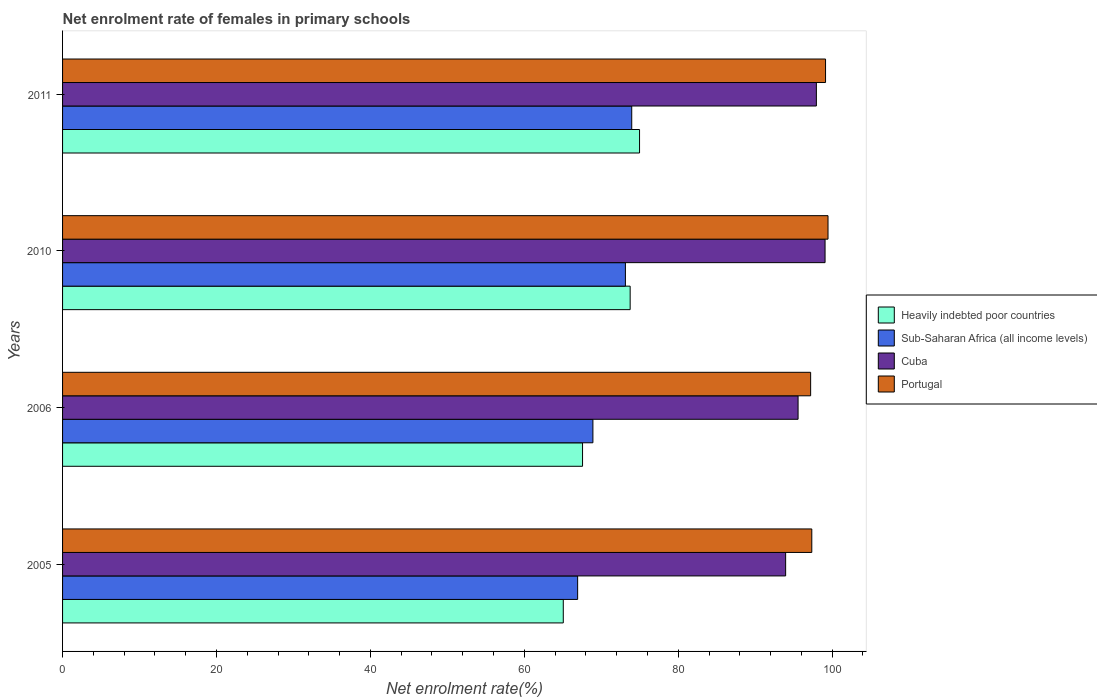Are the number of bars per tick equal to the number of legend labels?
Provide a succinct answer. Yes. How many bars are there on the 4th tick from the top?
Ensure brevity in your answer.  4. What is the net enrolment rate of females in primary schools in Portugal in 2010?
Keep it short and to the point. 99.46. Across all years, what is the maximum net enrolment rate of females in primary schools in Portugal?
Offer a very short reply. 99.46. Across all years, what is the minimum net enrolment rate of females in primary schools in Cuba?
Keep it short and to the point. 93.95. In which year was the net enrolment rate of females in primary schools in Heavily indebted poor countries maximum?
Ensure brevity in your answer.  2011. In which year was the net enrolment rate of females in primary schools in Portugal minimum?
Your answer should be very brief. 2006. What is the total net enrolment rate of females in primary schools in Sub-Saharan Africa (all income levels) in the graph?
Keep it short and to the point. 282.92. What is the difference between the net enrolment rate of females in primary schools in Heavily indebted poor countries in 2005 and that in 2011?
Provide a succinct answer. -9.91. What is the difference between the net enrolment rate of females in primary schools in Portugal in 2006 and the net enrolment rate of females in primary schools in Cuba in 2011?
Your answer should be very brief. -0.75. What is the average net enrolment rate of females in primary schools in Sub-Saharan Africa (all income levels) per year?
Make the answer very short. 70.73. In the year 2010, what is the difference between the net enrolment rate of females in primary schools in Portugal and net enrolment rate of females in primary schools in Sub-Saharan Africa (all income levels)?
Make the answer very short. 26.33. What is the ratio of the net enrolment rate of females in primary schools in Sub-Saharan Africa (all income levels) in 2005 to that in 2010?
Your answer should be very brief. 0.92. Is the net enrolment rate of females in primary schools in Cuba in 2006 less than that in 2010?
Ensure brevity in your answer.  Yes. What is the difference between the highest and the second highest net enrolment rate of females in primary schools in Heavily indebted poor countries?
Make the answer very short. 1.22. What is the difference between the highest and the lowest net enrolment rate of females in primary schools in Heavily indebted poor countries?
Ensure brevity in your answer.  9.91. What does the 2nd bar from the top in 2006 represents?
Your answer should be very brief. Cuba. What does the 1st bar from the bottom in 2005 represents?
Your answer should be compact. Heavily indebted poor countries. Is it the case that in every year, the sum of the net enrolment rate of females in primary schools in Heavily indebted poor countries and net enrolment rate of females in primary schools in Cuba is greater than the net enrolment rate of females in primary schools in Sub-Saharan Africa (all income levels)?
Make the answer very short. Yes. How many bars are there?
Provide a short and direct response. 16. Are all the bars in the graph horizontal?
Your answer should be very brief. Yes. What is the difference between two consecutive major ticks on the X-axis?
Your answer should be compact. 20. Does the graph contain grids?
Your response must be concise. No. Where does the legend appear in the graph?
Give a very brief answer. Center right. How are the legend labels stacked?
Keep it short and to the point. Vertical. What is the title of the graph?
Keep it short and to the point. Net enrolment rate of females in primary schools. Does "United Kingdom" appear as one of the legend labels in the graph?
Ensure brevity in your answer.  No. What is the label or title of the X-axis?
Keep it short and to the point. Net enrolment rate(%). What is the label or title of the Y-axis?
Give a very brief answer. Years. What is the Net enrolment rate(%) in Heavily indebted poor countries in 2005?
Ensure brevity in your answer.  65.06. What is the Net enrolment rate(%) in Sub-Saharan Africa (all income levels) in 2005?
Offer a very short reply. 66.92. What is the Net enrolment rate(%) in Cuba in 2005?
Keep it short and to the point. 93.95. What is the Net enrolment rate(%) in Portugal in 2005?
Your response must be concise. 97.35. What is the Net enrolment rate(%) in Heavily indebted poor countries in 2006?
Provide a succinct answer. 67.56. What is the Net enrolment rate(%) in Sub-Saharan Africa (all income levels) in 2006?
Offer a very short reply. 68.91. What is the Net enrolment rate(%) in Cuba in 2006?
Give a very brief answer. 95.57. What is the Net enrolment rate(%) of Portugal in 2006?
Offer a terse response. 97.2. What is the Net enrolment rate(%) in Heavily indebted poor countries in 2010?
Keep it short and to the point. 73.75. What is the Net enrolment rate(%) in Sub-Saharan Africa (all income levels) in 2010?
Provide a short and direct response. 73.13. What is the Net enrolment rate(%) in Cuba in 2010?
Give a very brief answer. 99.07. What is the Net enrolment rate(%) of Portugal in 2010?
Provide a short and direct response. 99.46. What is the Net enrolment rate(%) in Heavily indebted poor countries in 2011?
Make the answer very short. 74.97. What is the Net enrolment rate(%) in Sub-Saharan Africa (all income levels) in 2011?
Offer a terse response. 73.95. What is the Net enrolment rate(%) in Cuba in 2011?
Your answer should be compact. 97.94. What is the Net enrolment rate(%) of Portugal in 2011?
Provide a short and direct response. 99.14. Across all years, what is the maximum Net enrolment rate(%) in Heavily indebted poor countries?
Give a very brief answer. 74.97. Across all years, what is the maximum Net enrolment rate(%) of Sub-Saharan Africa (all income levels)?
Ensure brevity in your answer.  73.95. Across all years, what is the maximum Net enrolment rate(%) in Cuba?
Make the answer very short. 99.07. Across all years, what is the maximum Net enrolment rate(%) of Portugal?
Offer a terse response. 99.46. Across all years, what is the minimum Net enrolment rate(%) in Heavily indebted poor countries?
Make the answer very short. 65.06. Across all years, what is the minimum Net enrolment rate(%) of Sub-Saharan Africa (all income levels)?
Your answer should be compact. 66.92. Across all years, what is the minimum Net enrolment rate(%) of Cuba?
Provide a short and direct response. 93.95. Across all years, what is the minimum Net enrolment rate(%) in Portugal?
Make the answer very short. 97.2. What is the total Net enrolment rate(%) of Heavily indebted poor countries in the graph?
Give a very brief answer. 281.34. What is the total Net enrolment rate(%) of Sub-Saharan Africa (all income levels) in the graph?
Offer a very short reply. 282.92. What is the total Net enrolment rate(%) in Cuba in the graph?
Your answer should be compact. 386.54. What is the total Net enrolment rate(%) in Portugal in the graph?
Make the answer very short. 393.14. What is the difference between the Net enrolment rate(%) in Heavily indebted poor countries in 2005 and that in 2006?
Offer a terse response. -2.5. What is the difference between the Net enrolment rate(%) in Sub-Saharan Africa (all income levels) in 2005 and that in 2006?
Your response must be concise. -1.98. What is the difference between the Net enrolment rate(%) of Cuba in 2005 and that in 2006?
Keep it short and to the point. -1.62. What is the difference between the Net enrolment rate(%) of Portugal in 2005 and that in 2006?
Your answer should be very brief. 0.15. What is the difference between the Net enrolment rate(%) in Heavily indebted poor countries in 2005 and that in 2010?
Your answer should be very brief. -8.69. What is the difference between the Net enrolment rate(%) of Sub-Saharan Africa (all income levels) in 2005 and that in 2010?
Offer a terse response. -6.21. What is the difference between the Net enrolment rate(%) of Cuba in 2005 and that in 2010?
Ensure brevity in your answer.  -5.12. What is the difference between the Net enrolment rate(%) in Portugal in 2005 and that in 2010?
Your response must be concise. -2.11. What is the difference between the Net enrolment rate(%) in Heavily indebted poor countries in 2005 and that in 2011?
Your response must be concise. -9.91. What is the difference between the Net enrolment rate(%) of Sub-Saharan Africa (all income levels) in 2005 and that in 2011?
Make the answer very short. -7.03. What is the difference between the Net enrolment rate(%) of Cuba in 2005 and that in 2011?
Provide a succinct answer. -3.99. What is the difference between the Net enrolment rate(%) of Portugal in 2005 and that in 2011?
Provide a succinct answer. -1.79. What is the difference between the Net enrolment rate(%) of Heavily indebted poor countries in 2006 and that in 2010?
Make the answer very short. -6.19. What is the difference between the Net enrolment rate(%) in Sub-Saharan Africa (all income levels) in 2006 and that in 2010?
Ensure brevity in your answer.  -4.22. What is the difference between the Net enrolment rate(%) of Cuba in 2006 and that in 2010?
Make the answer very short. -3.51. What is the difference between the Net enrolment rate(%) in Portugal in 2006 and that in 2010?
Ensure brevity in your answer.  -2.26. What is the difference between the Net enrolment rate(%) of Heavily indebted poor countries in 2006 and that in 2011?
Offer a very short reply. -7.41. What is the difference between the Net enrolment rate(%) in Sub-Saharan Africa (all income levels) in 2006 and that in 2011?
Make the answer very short. -5.05. What is the difference between the Net enrolment rate(%) in Cuba in 2006 and that in 2011?
Your response must be concise. -2.38. What is the difference between the Net enrolment rate(%) of Portugal in 2006 and that in 2011?
Make the answer very short. -1.94. What is the difference between the Net enrolment rate(%) of Heavily indebted poor countries in 2010 and that in 2011?
Provide a short and direct response. -1.22. What is the difference between the Net enrolment rate(%) of Sub-Saharan Africa (all income levels) in 2010 and that in 2011?
Provide a short and direct response. -0.82. What is the difference between the Net enrolment rate(%) of Cuba in 2010 and that in 2011?
Your response must be concise. 1.13. What is the difference between the Net enrolment rate(%) of Portugal in 2010 and that in 2011?
Your response must be concise. 0.32. What is the difference between the Net enrolment rate(%) of Heavily indebted poor countries in 2005 and the Net enrolment rate(%) of Sub-Saharan Africa (all income levels) in 2006?
Your answer should be compact. -3.85. What is the difference between the Net enrolment rate(%) of Heavily indebted poor countries in 2005 and the Net enrolment rate(%) of Cuba in 2006?
Ensure brevity in your answer.  -30.51. What is the difference between the Net enrolment rate(%) in Heavily indebted poor countries in 2005 and the Net enrolment rate(%) in Portugal in 2006?
Your answer should be compact. -32.14. What is the difference between the Net enrolment rate(%) of Sub-Saharan Africa (all income levels) in 2005 and the Net enrolment rate(%) of Cuba in 2006?
Provide a succinct answer. -28.64. What is the difference between the Net enrolment rate(%) of Sub-Saharan Africa (all income levels) in 2005 and the Net enrolment rate(%) of Portugal in 2006?
Offer a very short reply. -30.27. What is the difference between the Net enrolment rate(%) of Cuba in 2005 and the Net enrolment rate(%) of Portugal in 2006?
Provide a succinct answer. -3.25. What is the difference between the Net enrolment rate(%) of Heavily indebted poor countries in 2005 and the Net enrolment rate(%) of Sub-Saharan Africa (all income levels) in 2010?
Make the answer very short. -8.07. What is the difference between the Net enrolment rate(%) in Heavily indebted poor countries in 2005 and the Net enrolment rate(%) in Cuba in 2010?
Keep it short and to the point. -34.01. What is the difference between the Net enrolment rate(%) of Heavily indebted poor countries in 2005 and the Net enrolment rate(%) of Portugal in 2010?
Keep it short and to the point. -34.4. What is the difference between the Net enrolment rate(%) of Sub-Saharan Africa (all income levels) in 2005 and the Net enrolment rate(%) of Cuba in 2010?
Offer a very short reply. -32.15. What is the difference between the Net enrolment rate(%) of Sub-Saharan Africa (all income levels) in 2005 and the Net enrolment rate(%) of Portugal in 2010?
Your answer should be very brief. -32.53. What is the difference between the Net enrolment rate(%) of Cuba in 2005 and the Net enrolment rate(%) of Portugal in 2010?
Keep it short and to the point. -5.51. What is the difference between the Net enrolment rate(%) in Heavily indebted poor countries in 2005 and the Net enrolment rate(%) in Sub-Saharan Africa (all income levels) in 2011?
Give a very brief answer. -8.89. What is the difference between the Net enrolment rate(%) of Heavily indebted poor countries in 2005 and the Net enrolment rate(%) of Cuba in 2011?
Your answer should be compact. -32.88. What is the difference between the Net enrolment rate(%) in Heavily indebted poor countries in 2005 and the Net enrolment rate(%) in Portugal in 2011?
Offer a terse response. -34.08. What is the difference between the Net enrolment rate(%) of Sub-Saharan Africa (all income levels) in 2005 and the Net enrolment rate(%) of Cuba in 2011?
Make the answer very short. -31.02. What is the difference between the Net enrolment rate(%) of Sub-Saharan Africa (all income levels) in 2005 and the Net enrolment rate(%) of Portugal in 2011?
Ensure brevity in your answer.  -32.21. What is the difference between the Net enrolment rate(%) of Cuba in 2005 and the Net enrolment rate(%) of Portugal in 2011?
Provide a succinct answer. -5.18. What is the difference between the Net enrolment rate(%) in Heavily indebted poor countries in 2006 and the Net enrolment rate(%) in Sub-Saharan Africa (all income levels) in 2010?
Keep it short and to the point. -5.57. What is the difference between the Net enrolment rate(%) in Heavily indebted poor countries in 2006 and the Net enrolment rate(%) in Cuba in 2010?
Your response must be concise. -31.51. What is the difference between the Net enrolment rate(%) of Heavily indebted poor countries in 2006 and the Net enrolment rate(%) of Portugal in 2010?
Keep it short and to the point. -31.9. What is the difference between the Net enrolment rate(%) in Sub-Saharan Africa (all income levels) in 2006 and the Net enrolment rate(%) in Cuba in 2010?
Provide a short and direct response. -30.16. What is the difference between the Net enrolment rate(%) of Sub-Saharan Africa (all income levels) in 2006 and the Net enrolment rate(%) of Portugal in 2010?
Offer a terse response. -30.55. What is the difference between the Net enrolment rate(%) in Cuba in 2006 and the Net enrolment rate(%) in Portugal in 2010?
Give a very brief answer. -3.89. What is the difference between the Net enrolment rate(%) in Heavily indebted poor countries in 2006 and the Net enrolment rate(%) in Sub-Saharan Africa (all income levels) in 2011?
Offer a very short reply. -6.39. What is the difference between the Net enrolment rate(%) of Heavily indebted poor countries in 2006 and the Net enrolment rate(%) of Cuba in 2011?
Give a very brief answer. -30.38. What is the difference between the Net enrolment rate(%) of Heavily indebted poor countries in 2006 and the Net enrolment rate(%) of Portugal in 2011?
Your answer should be compact. -31.57. What is the difference between the Net enrolment rate(%) in Sub-Saharan Africa (all income levels) in 2006 and the Net enrolment rate(%) in Cuba in 2011?
Offer a very short reply. -29.04. What is the difference between the Net enrolment rate(%) of Sub-Saharan Africa (all income levels) in 2006 and the Net enrolment rate(%) of Portugal in 2011?
Your answer should be compact. -30.23. What is the difference between the Net enrolment rate(%) in Cuba in 2006 and the Net enrolment rate(%) in Portugal in 2011?
Your answer should be compact. -3.57. What is the difference between the Net enrolment rate(%) of Heavily indebted poor countries in 2010 and the Net enrolment rate(%) of Sub-Saharan Africa (all income levels) in 2011?
Your answer should be very brief. -0.2. What is the difference between the Net enrolment rate(%) of Heavily indebted poor countries in 2010 and the Net enrolment rate(%) of Cuba in 2011?
Offer a very short reply. -24.2. What is the difference between the Net enrolment rate(%) of Heavily indebted poor countries in 2010 and the Net enrolment rate(%) of Portugal in 2011?
Make the answer very short. -25.39. What is the difference between the Net enrolment rate(%) in Sub-Saharan Africa (all income levels) in 2010 and the Net enrolment rate(%) in Cuba in 2011?
Offer a very short reply. -24.81. What is the difference between the Net enrolment rate(%) of Sub-Saharan Africa (all income levels) in 2010 and the Net enrolment rate(%) of Portugal in 2011?
Provide a succinct answer. -26. What is the difference between the Net enrolment rate(%) of Cuba in 2010 and the Net enrolment rate(%) of Portugal in 2011?
Your response must be concise. -0.06. What is the average Net enrolment rate(%) in Heavily indebted poor countries per year?
Provide a succinct answer. 70.34. What is the average Net enrolment rate(%) in Sub-Saharan Africa (all income levels) per year?
Offer a very short reply. 70.73. What is the average Net enrolment rate(%) of Cuba per year?
Your answer should be very brief. 96.63. What is the average Net enrolment rate(%) in Portugal per year?
Make the answer very short. 98.29. In the year 2005, what is the difference between the Net enrolment rate(%) in Heavily indebted poor countries and Net enrolment rate(%) in Sub-Saharan Africa (all income levels)?
Provide a short and direct response. -1.86. In the year 2005, what is the difference between the Net enrolment rate(%) of Heavily indebted poor countries and Net enrolment rate(%) of Cuba?
Give a very brief answer. -28.89. In the year 2005, what is the difference between the Net enrolment rate(%) of Heavily indebted poor countries and Net enrolment rate(%) of Portugal?
Give a very brief answer. -32.29. In the year 2005, what is the difference between the Net enrolment rate(%) in Sub-Saharan Africa (all income levels) and Net enrolment rate(%) in Cuba?
Ensure brevity in your answer.  -27.03. In the year 2005, what is the difference between the Net enrolment rate(%) of Sub-Saharan Africa (all income levels) and Net enrolment rate(%) of Portugal?
Offer a terse response. -30.43. In the year 2005, what is the difference between the Net enrolment rate(%) in Cuba and Net enrolment rate(%) in Portugal?
Offer a very short reply. -3.4. In the year 2006, what is the difference between the Net enrolment rate(%) in Heavily indebted poor countries and Net enrolment rate(%) in Sub-Saharan Africa (all income levels)?
Your answer should be compact. -1.35. In the year 2006, what is the difference between the Net enrolment rate(%) of Heavily indebted poor countries and Net enrolment rate(%) of Cuba?
Keep it short and to the point. -28.01. In the year 2006, what is the difference between the Net enrolment rate(%) in Heavily indebted poor countries and Net enrolment rate(%) in Portugal?
Your answer should be compact. -29.64. In the year 2006, what is the difference between the Net enrolment rate(%) of Sub-Saharan Africa (all income levels) and Net enrolment rate(%) of Cuba?
Provide a succinct answer. -26.66. In the year 2006, what is the difference between the Net enrolment rate(%) of Sub-Saharan Africa (all income levels) and Net enrolment rate(%) of Portugal?
Offer a very short reply. -28.29. In the year 2006, what is the difference between the Net enrolment rate(%) of Cuba and Net enrolment rate(%) of Portugal?
Provide a succinct answer. -1.63. In the year 2010, what is the difference between the Net enrolment rate(%) of Heavily indebted poor countries and Net enrolment rate(%) of Sub-Saharan Africa (all income levels)?
Offer a very short reply. 0.62. In the year 2010, what is the difference between the Net enrolment rate(%) of Heavily indebted poor countries and Net enrolment rate(%) of Cuba?
Provide a short and direct response. -25.32. In the year 2010, what is the difference between the Net enrolment rate(%) of Heavily indebted poor countries and Net enrolment rate(%) of Portugal?
Keep it short and to the point. -25.71. In the year 2010, what is the difference between the Net enrolment rate(%) in Sub-Saharan Africa (all income levels) and Net enrolment rate(%) in Cuba?
Give a very brief answer. -25.94. In the year 2010, what is the difference between the Net enrolment rate(%) of Sub-Saharan Africa (all income levels) and Net enrolment rate(%) of Portugal?
Offer a very short reply. -26.32. In the year 2010, what is the difference between the Net enrolment rate(%) in Cuba and Net enrolment rate(%) in Portugal?
Give a very brief answer. -0.38. In the year 2011, what is the difference between the Net enrolment rate(%) of Heavily indebted poor countries and Net enrolment rate(%) of Sub-Saharan Africa (all income levels)?
Keep it short and to the point. 1.02. In the year 2011, what is the difference between the Net enrolment rate(%) in Heavily indebted poor countries and Net enrolment rate(%) in Cuba?
Your answer should be very brief. -22.98. In the year 2011, what is the difference between the Net enrolment rate(%) in Heavily indebted poor countries and Net enrolment rate(%) in Portugal?
Offer a very short reply. -24.17. In the year 2011, what is the difference between the Net enrolment rate(%) in Sub-Saharan Africa (all income levels) and Net enrolment rate(%) in Cuba?
Your answer should be compact. -23.99. In the year 2011, what is the difference between the Net enrolment rate(%) in Sub-Saharan Africa (all income levels) and Net enrolment rate(%) in Portugal?
Provide a succinct answer. -25.18. In the year 2011, what is the difference between the Net enrolment rate(%) in Cuba and Net enrolment rate(%) in Portugal?
Your answer should be compact. -1.19. What is the ratio of the Net enrolment rate(%) in Sub-Saharan Africa (all income levels) in 2005 to that in 2006?
Your answer should be very brief. 0.97. What is the ratio of the Net enrolment rate(%) of Cuba in 2005 to that in 2006?
Offer a very short reply. 0.98. What is the ratio of the Net enrolment rate(%) in Heavily indebted poor countries in 2005 to that in 2010?
Your answer should be compact. 0.88. What is the ratio of the Net enrolment rate(%) of Sub-Saharan Africa (all income levels) in 2005 to that in 2010?
Give a very brief answer. 0.92. What is the ratio of the Net enrolment rate(%) of Cuba in 2005 to that in 2010?
Your answer should be compact. 0.95. What is the ratio of the Net enrolment rate(%) in Portugal in 2005 to that in 2010?
Make the answer very short. 0.98. What is the ratio of the Net enrolment rate(%) of Heavily indebted poor countries in 2005 to that in 2011?
Make the answer very short. 0.87. What is the ratio of the Net enrolment rate(%) in Sub-Saharan Africa (all income levels) in 2005 to that in 2011?
Your answer should be very brief. 0.9. What is the ratio of the Net enrolment rate(%) in Cuba in 2005 to that in 2011?
Your answer should be compact. 0.96. What is the ratio of the Net enrolment rate(%) in Heavily indebted poor countries in 2006 to that in 2010?
Provide a short and direct response. 0.92. What is the ratio of the Net enrolment rate(%) in Sub-Saharan Africa (all income levels) in 2006 to that in 2010?
Your response must be concise. 0.94. What is the ratio of the Net enrolment rate(%) in Cuba in 2006 to that in 2010?
Offer a very short reply. 0.96. What is the ratio of the Net enrolment rate(%) in Portugal in 2006 to that in 2010?
Ensure brevity in your answer.  0.98. What is the ratio of the Net enrolment rate(%) in Heavily indebted poor countries in 2006 to that in 2011?
Keep it short and to the point. 0.9. What is the ratio of the Net enrolment rate(%) in Sub-Saharan Africa (all income levels) in 2006 to that in 2011?
Provide a succinct answer. 0.93. What is the ratio of the Net enrolment rate(%) in Cuba in 2006 to that in 2011?
Give a very brief answer. 0.98. What is the ratio of the Net enrolment rate(%) in Portugal in 2006 to that in 2011?
Keep it short and to the point. 0.98. What is the ratio of the Net enrolment rate(%) in Heavily indebted poor countries in 2010 to that in 2011?
Your answer should be compact. 0.98. What is the ratio of the Net enrolment rate(%) in Sub-Saharan Africa (all income levels) in 2010 to that in 2011?
Make the answer very short. 0.99. What is the ratio of the Net enrolment rate(%) in Cuba in 2010 to that in 2011?
Provide a short and direct response. 1.01. What is the difference between the highest and the second highest Net enrolment rate(%) of Heavily indebted poor countries?
Make the answer very short. 1.22. What is the difference between the highest and the second highest Net enrolment rate(%) in Sub-Saharan Africa (all income levels)?
Offer a terse response. 0.82. What is the difference between the highest and the second highest Net enrolment rate(%) of Cuba?
Offer a terse response. 1.13. What is the difference between the highest and the second highest Net enrolment rate(%) in Portugal?
Offer a very short reply. 0.32. What is the difference between the highest and the lowest Net enrolment rate(%) in Heavily indebted poor countries?
Your response must be concise. 9.91. What is the difference between the highest and the lowest Net enrolment rate(%) of Sub-Saharan Africa (all income levels)?
Your response must be concise. 7.03. What is the difference between the highest and the lowest Net enrolment rate(%) of Cuba?
Provide a short and direct response. 5.12. What is the difference between the highest and the lowest Net enrolment rate(%) in Portugal?
Keep it short and to the point. 2.26. 